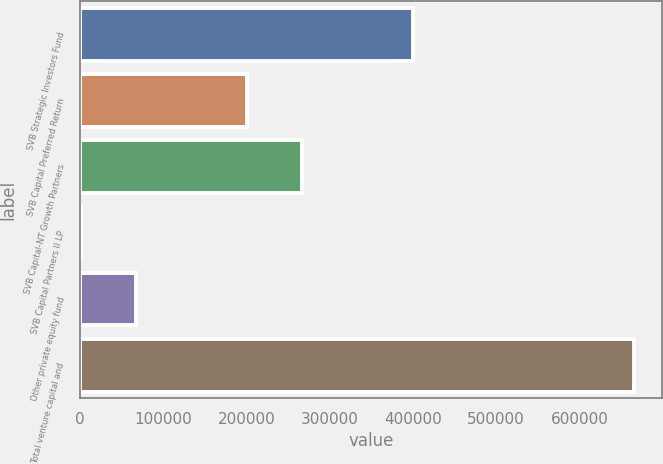Convert chart to OTSL. <chart><loc_0><loc_0><loc_500><loc_500><bar_chart><fcel>SVB Strategic Investors Fund<fcel>SVB Capital Preferred Return<fcel>SVB Capital-NT Growth Partners<fcel>SVB Capital Partners II LP<fcel>Other private equity fund<fcel>Total venture capital and<nl><fcel>400074<fcel>200688<fcel>267150<fcel>1303<fcel>67764.8<fcel>665921<nl></chart> 